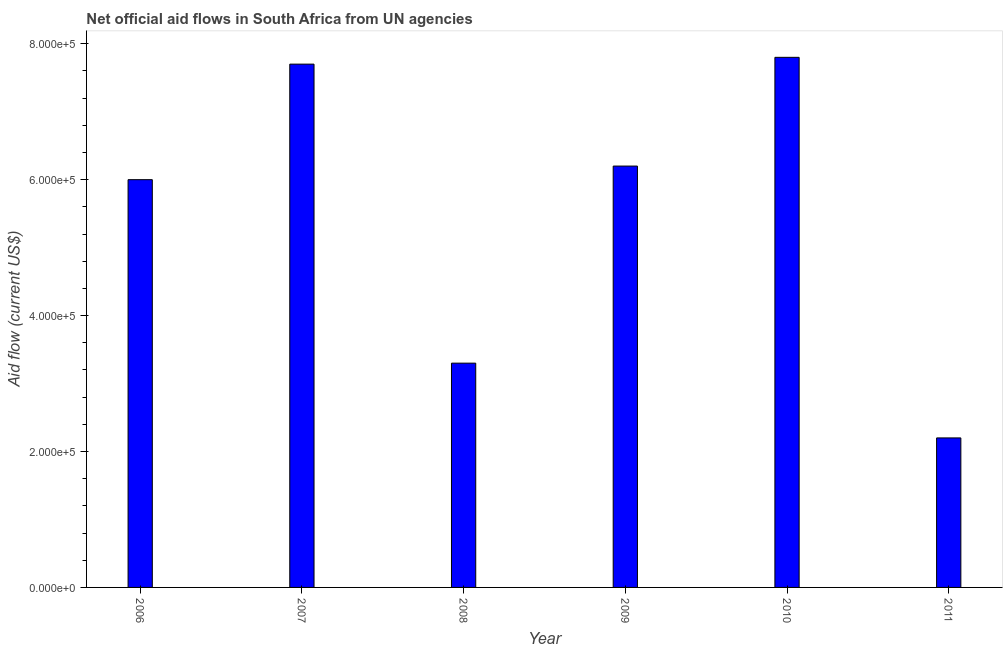What is the title of the graph?
Keep it short and to the point. Net official aid flows in South Africa from UN agencies. What is the label or title of the Y-axis?
Offer a terse response. Aid flow (current US$). What is the net official flows from un agencies in 2010?
Offer a terse response. 7.80e+05. Across all years, what is the maximum net official flows from un agencies?
Your answer should be compact. 7.80e+05. Across all years, what is the minimum net official flows from un agencies?
Your response must be concise. 2.20e+05. In which year was the net official flows from un agencies maximum?
Offer a terse response. 2010. In which year was the net official flows from un agencies minimum?
Offer a terse response. 2011. What is the sum of the net official flows from un agencies?
Make the answer very short. 3.32e+06. What is the average net official flows from un agencies per year?
Your response must be concise. 5.53e+05. In how many years, is the net official flows from un agencies greater than 240000 US$?
Provide a succinct answer. 5. What is the ratio of the net official flows from un agencies in 2007 to that in 2008?
Provide a succinct answer. 2.33. What is the difference between the highest and the lowest net official flows from un agencies?
Offer a very short reply. 5.60e+05. Are all the bars in the graph horizontal?
Make the answer very short. No. What is the difference between two consecutive major ticks on the Y-axis?
Your answer should be very brief. 2.00e+05. Are the values on the major ticks of Y-axis written in scientific E-notation?
Keep it short and to the point. Yes. What is the Aid flow (current US$) in 2007?
Ensure brevity in your answer.  7.70e+05. What is the Aid flow (current US$) in 2008?
Your response must be concise. 3.30e+05. What is the Aid flow (current US$) of 2009?
Your answer should be compact. 6.20e+05. What is the Aid flow (current US$) of 2010?
Provide a succinct answer. 7.80e+05. What is the Aid flow (current US$) in 2011?
Your answer should be very brief. 2.20e+05. What is the difference between the Aid flow (current US$) in 2006 and 2007?
Provide a short and direct response. -1.70e+05. What is the difference between the Aid flow (current US$) in 2006 and 2008?
Provide a short and direct response. 2.70e+05. What is the difference between the Aid flow (current US$) in 2006 and 2010?
Your response must be concise. -1.80e+05. What is the difference between the Aid flow (current US$) in 2006 and 2011?
Provide a short and direct response. 3.80e+05. What is the difference between the Aid flow (current US$) in 2007 and 2008?
Offer a terse response. 4.40e+05. What is the difference between the Aid flow (current US$) in 2007 and 2011?
Offer a terse response. 5.50e+05. What is the difference between the Aid flow (current US$) in 2008 and 2009?
Your answer should be very brief. -2.90e+05. What is the difference between the Aid flow (current US$) in 2008 and 2010?
Your response must be concise. -4.50e+05. What is the difference between the Aid flow (current US$) in 2008 and 2011?
Make the answer very short. 1.10e+05. What is the difference between the Aid flow (current US$) in 2009 and 2010?
Provide a short and direct response. -1.60e+05. What is the difference between the Aid flow (current US$) in 2009 and 2011?
Keep it short and to the point. 4.00e+05. What is the difference between the Aid flow (current US$) in 2010 and 2011?
Provide a short and direct response. 5.60e+05. What is the ratio of the Aid flow (current US$) in 2006 to that in 2007?
Your answer should be compact. 0.78. What is the ratio of the Aid flow (current US$) in 2006 to that in 2008?
Your answer should be very brief. 1.82. What is the ratio of the Aid flow (current US$) in 2006 to that in 2009?
Give a very brief answer. 0.97. What is the ratio of the Aid flow (current US$) in 2006 to that in 2010?
Your answer should be compact. 0.77. What is the ratio of the Aid flow (current US$) in 2006 to that in 2011?
Ensure brevity in your answer.  2.73. What is the ratio of the Aid flow (current US$) in 2007 to that in 2008?
Make the answer very short. 2.33. What is the ratio of the Aid flow (current US$) in 2007 to that in 2009?
Give a very brief answer. 1.24. What is the ratio of the Aid flow (current US$) in 2007 to that in 2011?
Provide a short and direct response. 3.5. What is the ratio of the Aid flow (current US$) in 2008 to that in 2009?
Make the answer very short. 0.53. What is the ratio of the Aid flow (current US$) in 2008 to that in 2010?
Your answer should be very brief. 0.42. What is the ratio of the Aid flow (current US$) in 2009 to that in 2010?
Your answer should be very brief. 0.8. What is the ratio of the Aid flow (current US$) in 2009 to that in 2011?
Your answer should be compact. 2.82. What is the ratio of the Aid flow (current US$) in 2010 to that in 2011?
Provide a short and direct response. 3.54. 